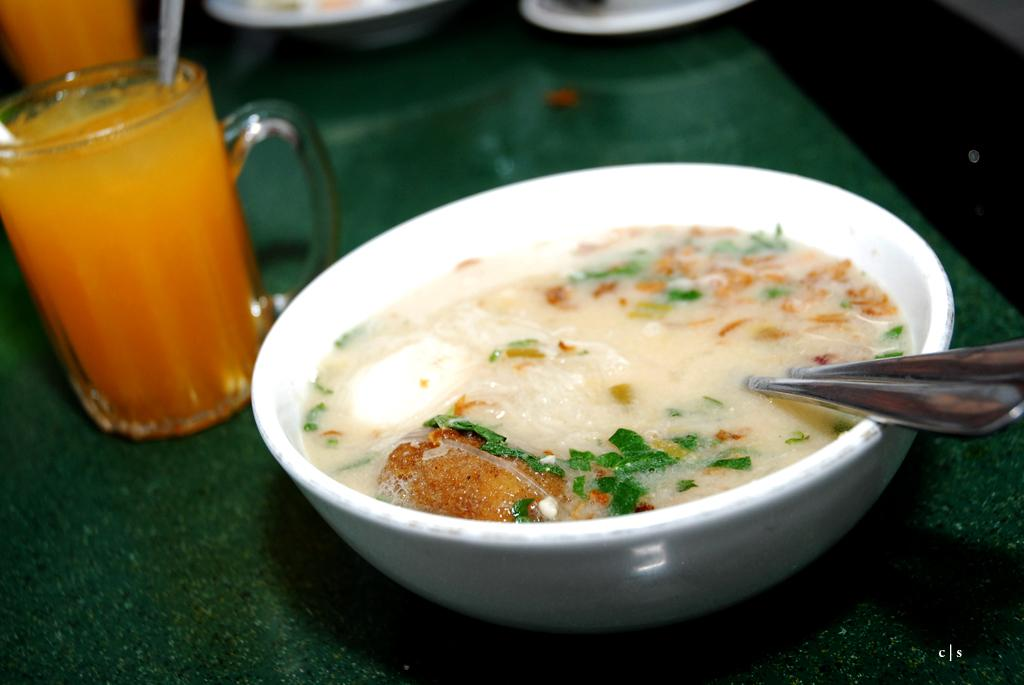What is in the bowl that is visible in the image? There is a bowl with food items in the image. What other object can be seen on the left side of the image? There is a glass on the left side of the image. What type of respect can be seen being given to the police in the image? There is no police presence in the image, so it is not possible to determine if any respect is being given. 